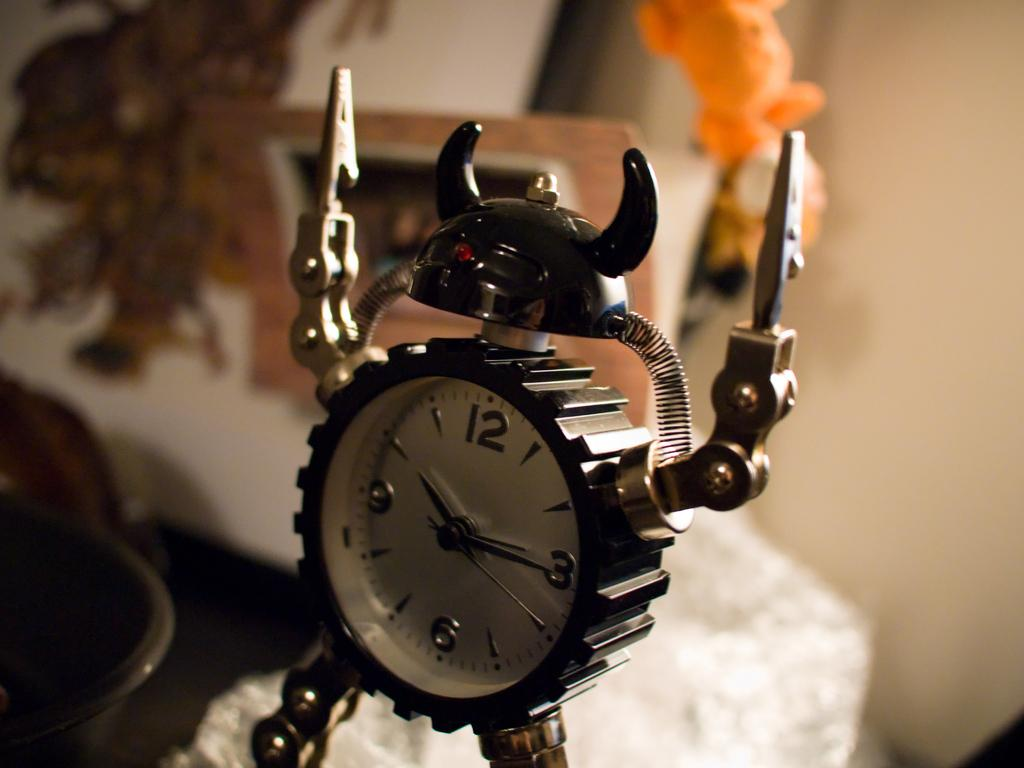<image>
Write a terse but informative summary of the picture. A mini clock showing the time of 10:15. 